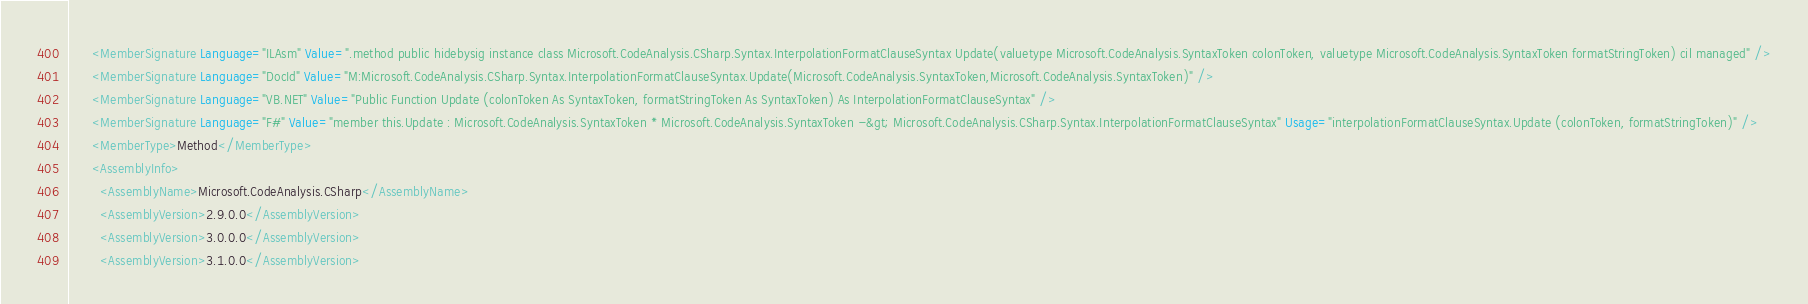<code> <loc_0><loc_0><loc_500><loc_500><_XML_>      <MemberSignature Language="ILAsm" Value=".method public hidebysig instance class Microsoft.CodeAnalysis.CSharp.Syntax.InterpolationFormatClauseSyntax Update(valuetype Microsoft.CodeAnalysis.SyntaxToken colonToken, valuetype Microsoft.CodeAnalysis.SyntaxToken formatStringToken) cil managed" />
      <MemberSignature Language="DocId" Value="M:Microsoft.CodeAnalysis.CSharp.Syntax.InterpolationFormatClauseSyntax.Update(Microsoft.CodeAnalysis.SyntaxToken,Microsoft.CodeAnalysis.SyntaxToken)" />
      <MemberSignature Language="VB.NET" Value="Public Function Update (colonToken As SyntaxToken, formatStringToken As SyntaxToken) As InterpolationFormatClauseSyntax" />
      <MemberSignature Language="F#" Value="member this.Update : Microsoft.CodeAnalysis.SyntaxToken * Microsoft.CodeAnalysis.SyntaxToken -&gt; Microsoft.CodeAnalysis.CSharp.Syntax.InterpolationFormatClauseSyntax" Usage="interpolationFormatClauseSyntax.Update (colonToken, formatStringToken)" />
      <MemberType>Method</MemberType>
      <AssemblyInfo>
        <AssemblyName>Microsoft.CodeAnalysis.CSharp</AssemblyName>
        <AssemblyVersion>2.9.0.0</AssemblyVersion>
        <AssemblyVersion>3.0.0.0</AssemblyVersion>
        <AssemblyVersion>3.1.0.0</AssemblyVersion></code> 